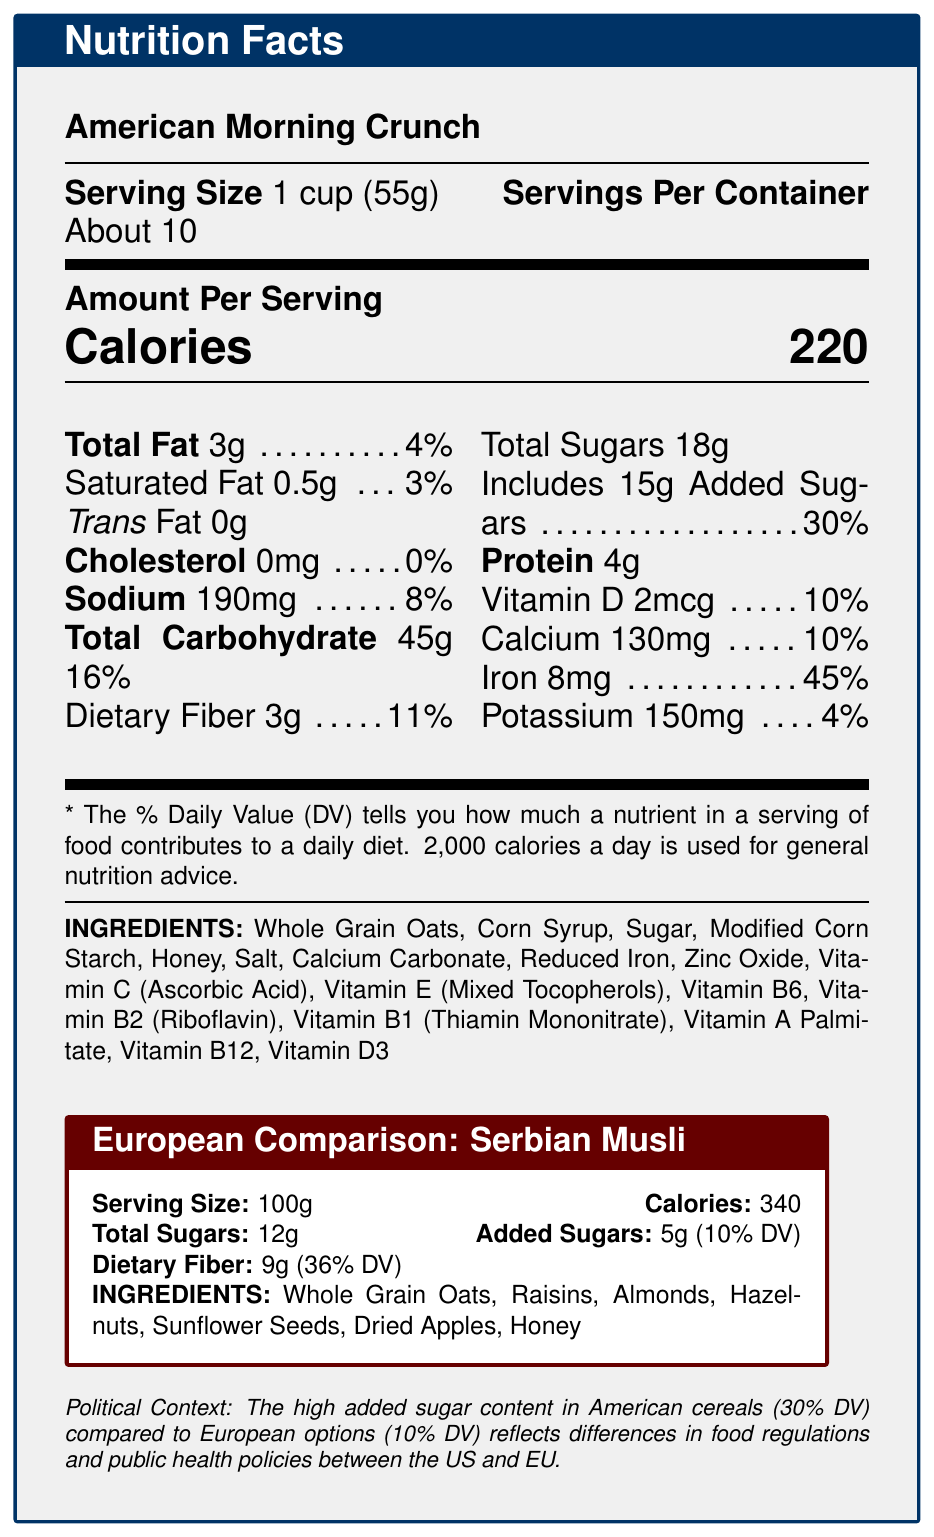What is the serving size of American Morning Crunch cereal? The document lists "Serving Size" as "1 cup (55g)".
Answer: 1 cup (55g) How much dietary fiber is in one serving of American Morning Crunch? The nutrition facts indicate "Dietary Fiber" as "3g".
Answer: 3g What is the percentage daily value of iron in American Morning Crunch cereal? The document states that the percentage daily value of iron is 45%.
Answer: 45% How many grams of added sugars are there in American Morning Crunch? The nutrition facts show "Includes 15g Added Sugars".
Answer: 15g What is the main ingredient in Serbian Musli? The listed main ingredient of Serbian Musli is "Whole Grain Oats".
Answer: Whole Grain Oats Which cereal has more dietary fiber per serving? A. American Morning Crunch B. Serbian Musli C. Both have the same amount of dietary fiber The document shows that American Morning Crunch has 3g per 55g serving, while Serbian Musli has 9g per 100g, but in relative terms, Serbian Musli still has a higher amount.
Answer: B What is the calories count for one serving of Serbian Musli? A. 220 B. 340 C. 150 D. 100 The document indicates the calorie count as 340 for a 100g serving of Serbian Musli.
Answer: B Does American Morning Crunch cereal contain any trans fat? The nutrition facts show that the amount of trans fat is 0g.
Answer: No Does American Morning Crunch have any cholesterol? The nutrition facts indicate that the cholesterol content is 0mg.
Answer: No What are the key differences in sugar content between American Morning Crunch and Serbian Musli? By comparing the sugar content, American Morning Crunch has higher added sugars and total sugars.
Answer: American Morning Crunch contains more added sugars with 15g compared to Serbian Musli's 5g; Total sugars in American Morning Crunch are 18g, while Serbian Musli has 12g. What is the total amount of sugars in Serbian Musli? The document lists the total sugars for Serbian Musli as 12g.
Answer: 12g What ingredient is common in both American Morning Crunch and Serbian Musli? Both ingredient lists include "Whole Grain Oats".
Answer: Whole Grain Oats How do the added sugars in American Morning Crunch compare to the recommended daily value (DV)? The nutrition facts state that the added sugars are 15g, which is 30% of the daily value.
Answer: 30% Summarize the main differences between American Morning Crunch and Serbian Musli in this document. The document highlights significant nutritional differences between the two, where the American cereal has higher added sugars and lower dietary fiber compared to the European option.
Answer: American Morning Crunch has 220 calories per 55g serving, with 3g of dietary fiber, 18g of total sugars including 15g added sugars, and a higher iron percentage at 45%. Serbian Musli, per 100g, has 340 calories, 9g of dietary fiber, 12g total sugars including 5g added sugars, and no iron listed. American Morning Crunch's composition reflects higher sugars and iron, while Serbian Musli focuses more on dietary fiber with lower added sugars. What is the sodium content of American Morning Crunch? The nutrition facts list "Sodium" as "190mg".
Answer: 190mg Are whole grain oats present in American Morning Crunch cereal? The ingredient list includes "Whole Grain Oats".
Answer: Yes What percentage daily value of dietary fiber is provided by Serbian Musli? The document shows that Serbian Musli provides 36% of the daily value for dietary fiber.
Answer: 36% Can you determine the specific amounts of all vitamins present in American Morning Crunch? The document lists some vitamins with their amounts and percentages, but not all specific amounts are provided. For example, Vitamin B6, Vitamin B2, and others have no specific amounts listed.
Answer: Not enough information 